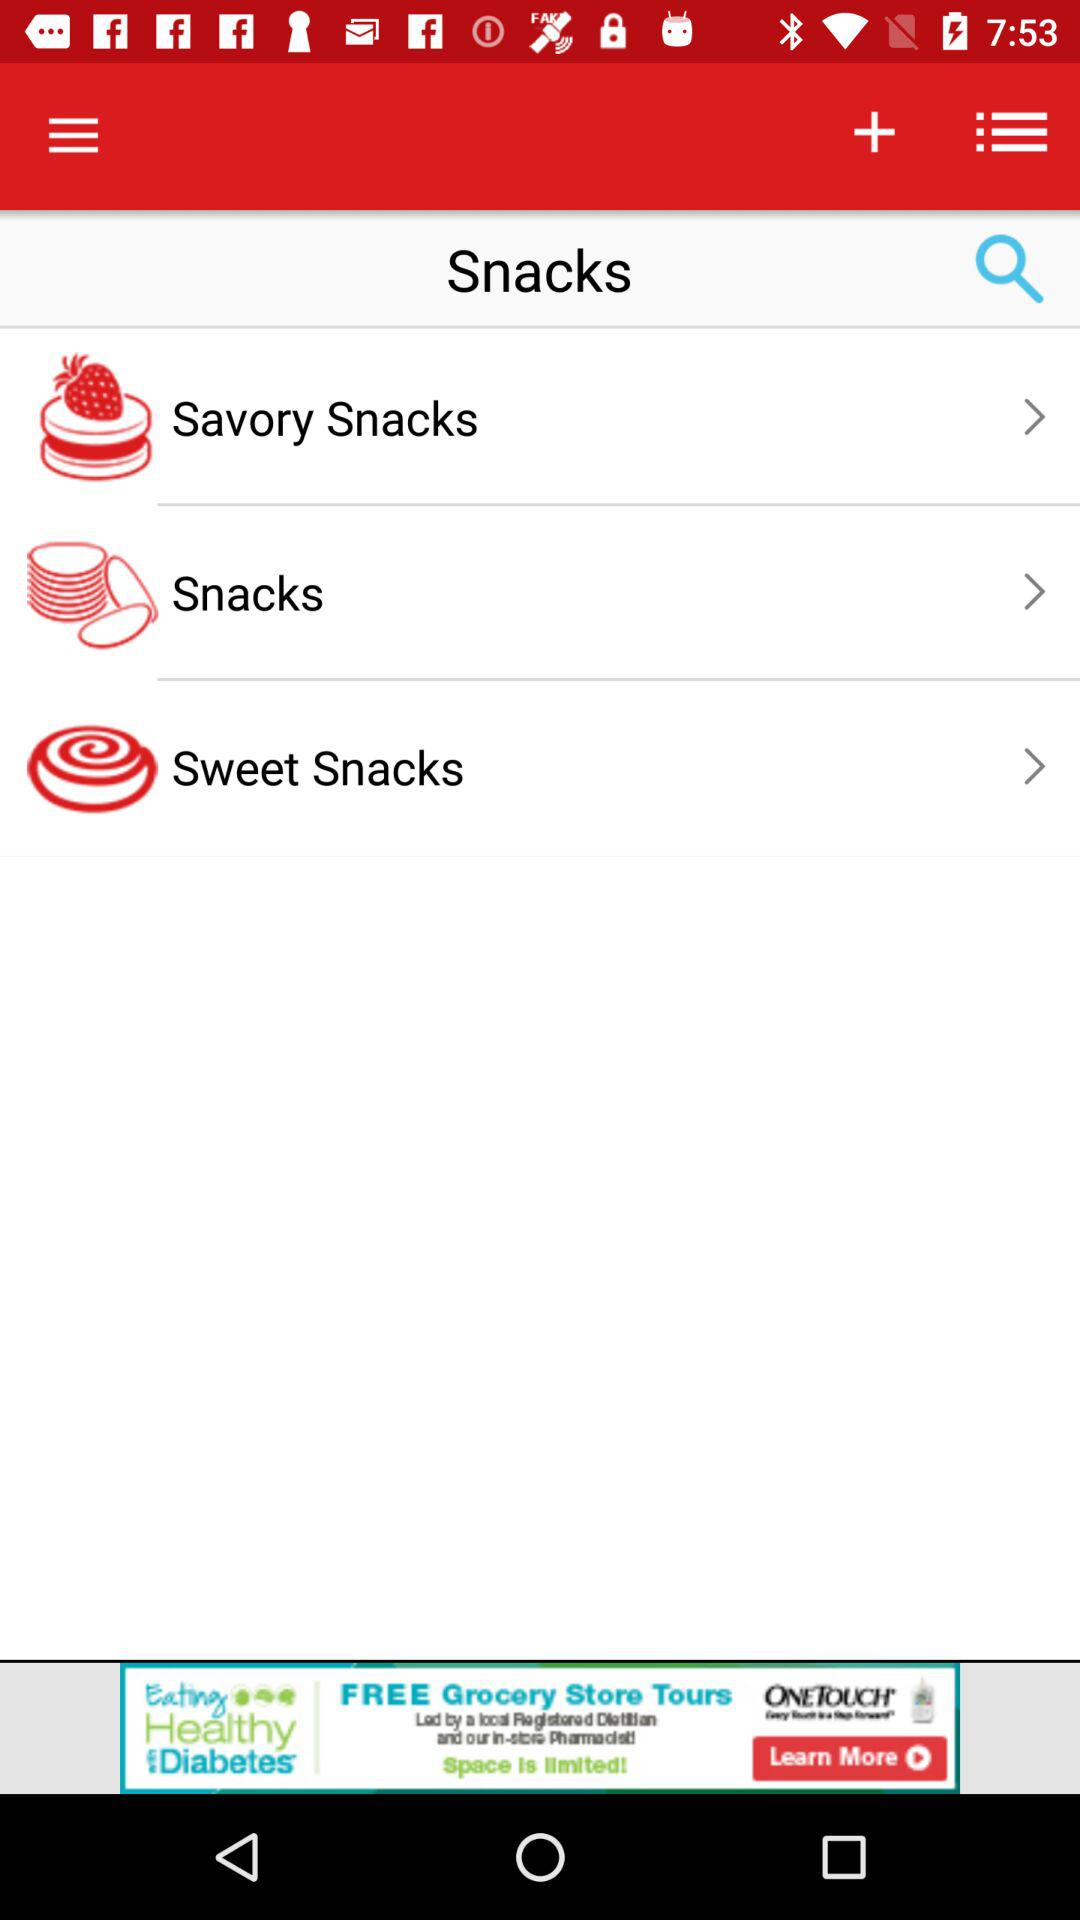How many items are in the Snacks category?
Answer the question using a single word or phrase. 3 